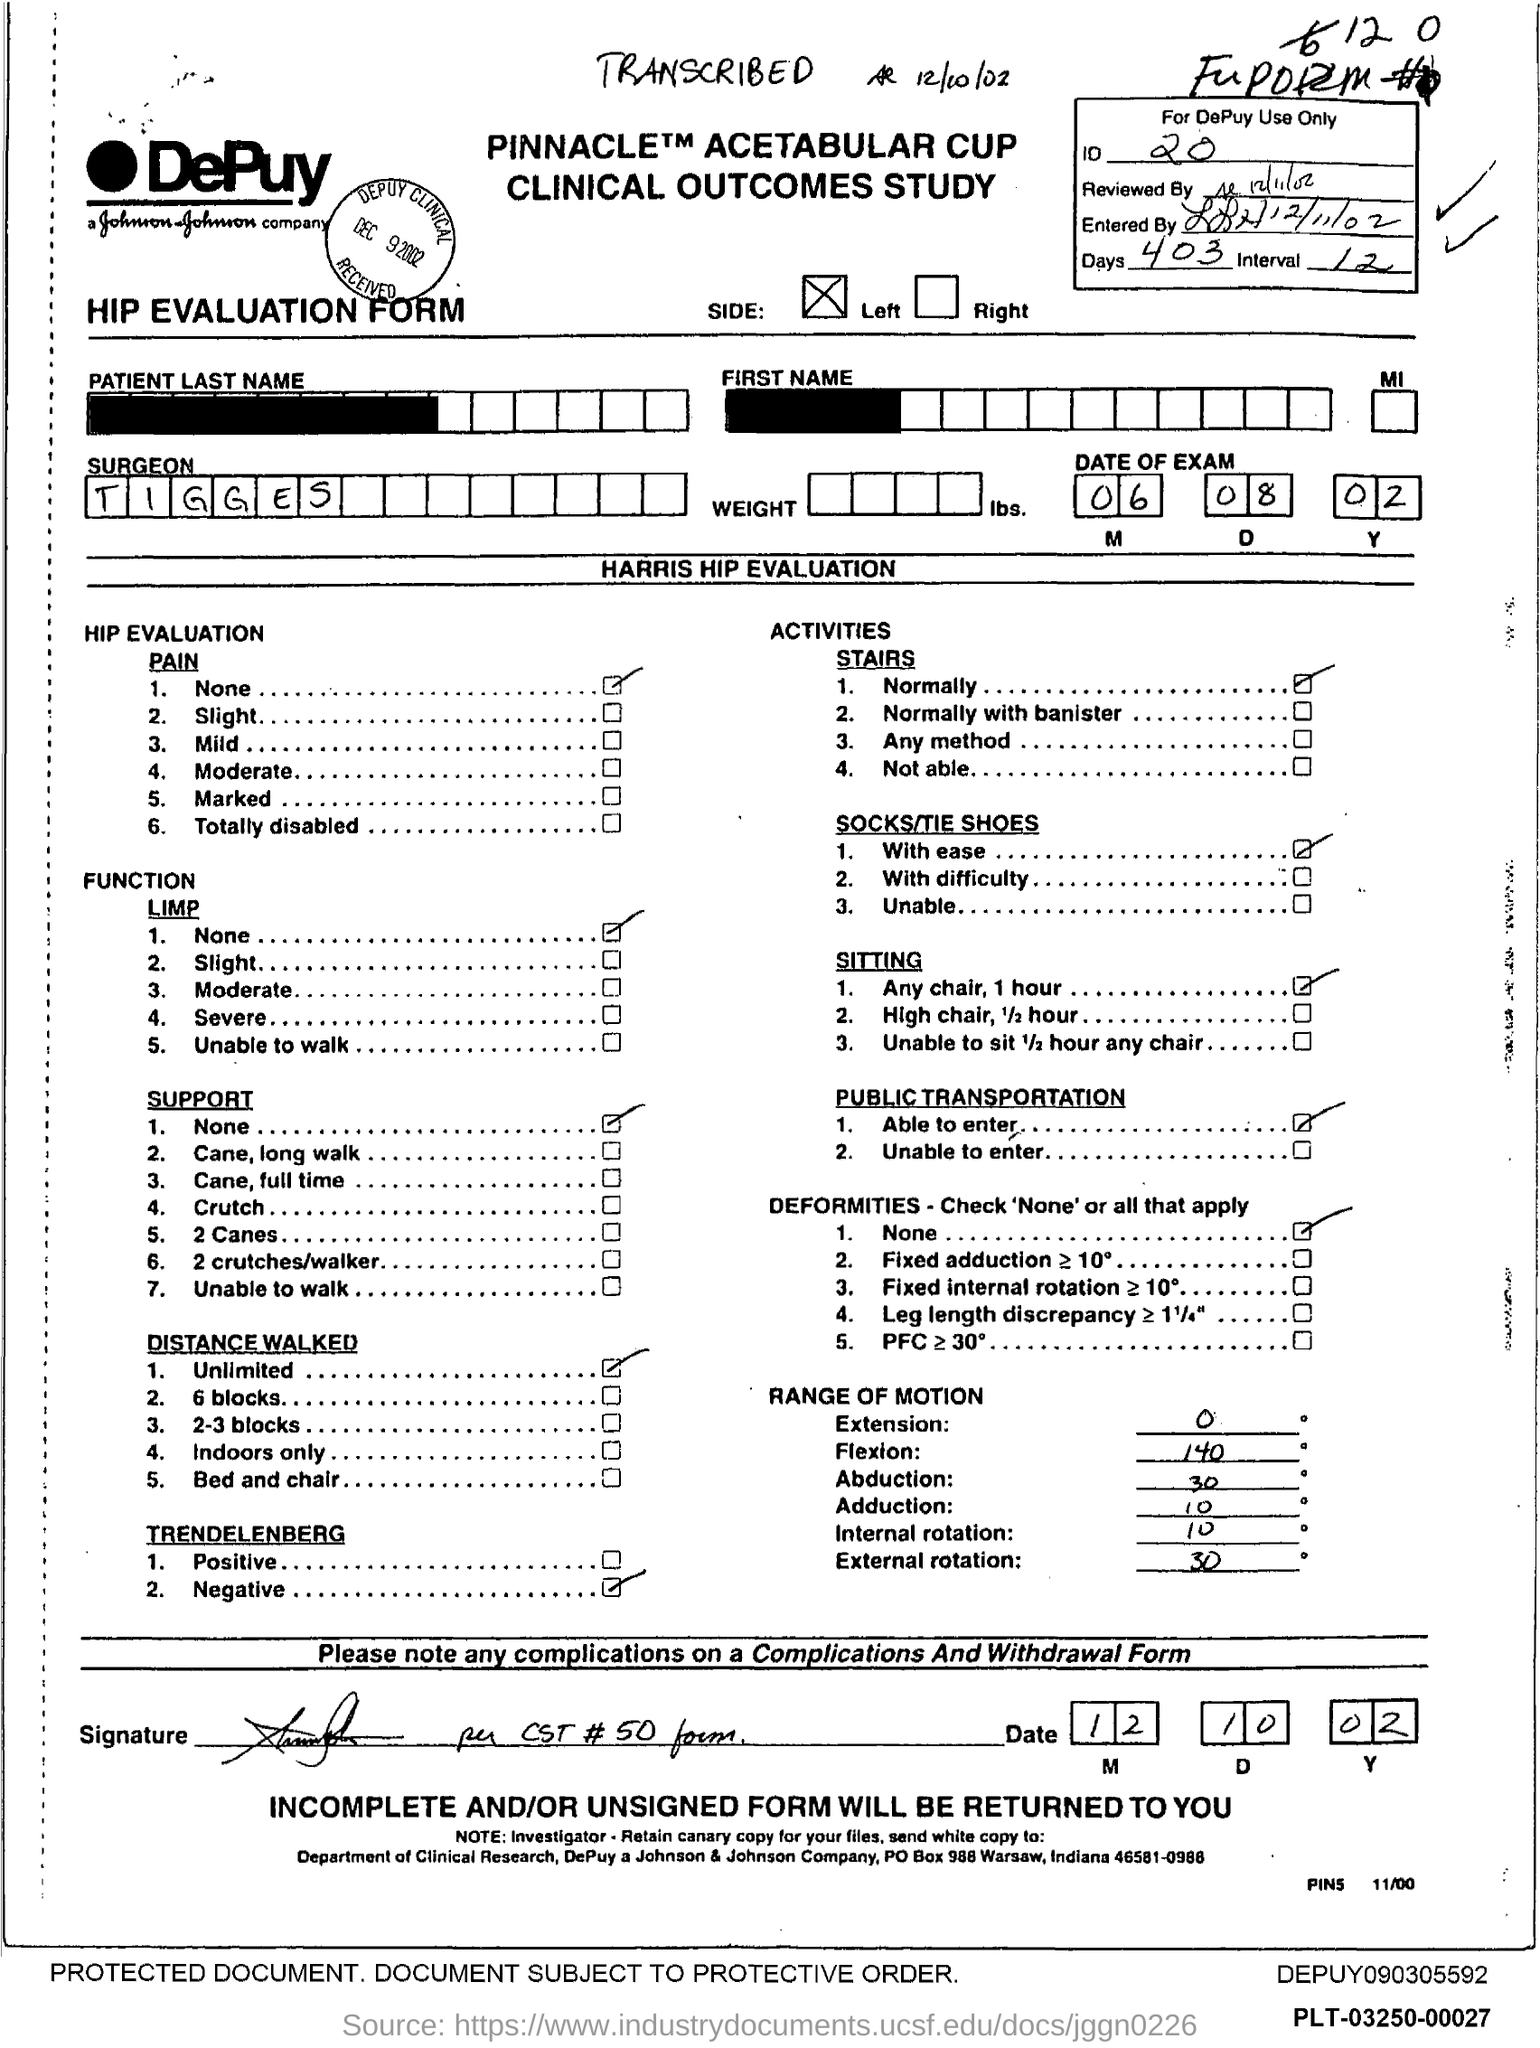Mention a couple of crucial points in this snapshot. The surgeon's name is Tigges. The number of days is 403. The ID number is 20. 